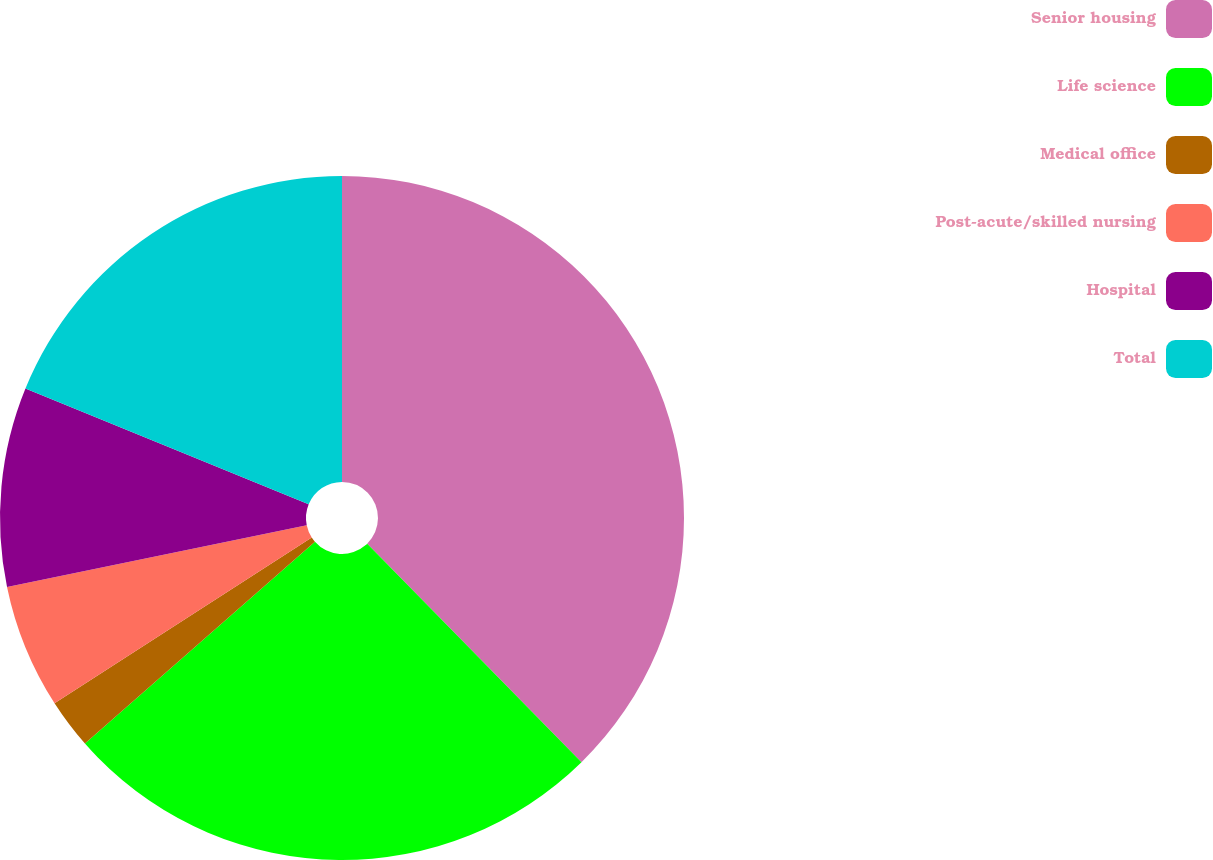Convert chart to OTSL. <chart><loc_0><loc_0><loc_500><loc_500><pie_chart><fcel>Senior housing<fcel>Life science<fcel>Medical office<fcel>Post-acute/skilled nursing<fcel>Hospital<fcel>Total<nl><fcel>37.65%<fcel>25.88%<fcel>2.35%<fcel>5.88%<fcel>9.41%<fcel>18.82%<nl></chart> 